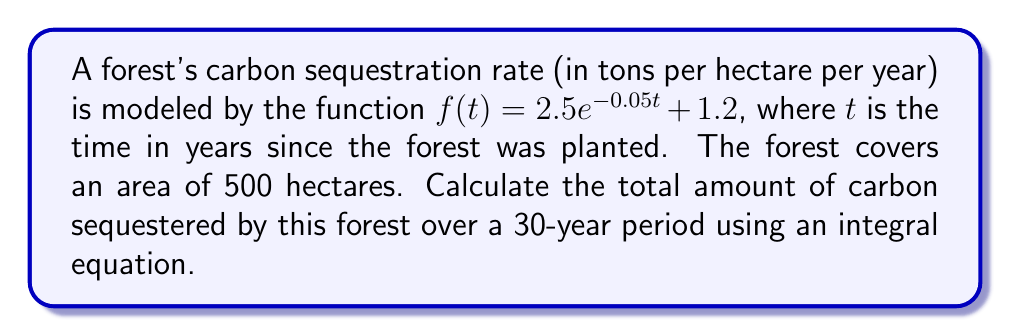Show me your answer to this math problem. To solve this problem, we need to follow these steps:

1) The total carbon sequestered over time is the integral of the sequestration rate function multiplied by the forest area.

2) Set up the integral equation:
   $$\text{Total Carbon} = 500 \int_0^{30} (2.5e^{-0.05t} + 1.2) dt$$

3) Solve the integral:
   $$500 \int_0^{30} (2.5e^{-0.05t} + 1.2) dt$$
   $$= 500 \left[-50e^{-0.05t} + 1.2t\right]_0^{30}$$

4) Evaluate the definite integral:
   $$= 500 \left[(-50e^{-0.05(30)} + 1.2(30)) - (-50e^{-0.05(0)} + 1.2(0))\right]$$
   $$= 500 \left[-50(0.2231) + 36 - (-50 + 0)\right]$$
   $$= 500 [(-11.155 + 36) - (-50)]$$
   $$= 500 [24.845 + 50]$$
   $$= 500 (74.845)$$
   $$= 37,422.5$$

5) The result is in tons of carbon.
Answer: 37,422.5 tons 